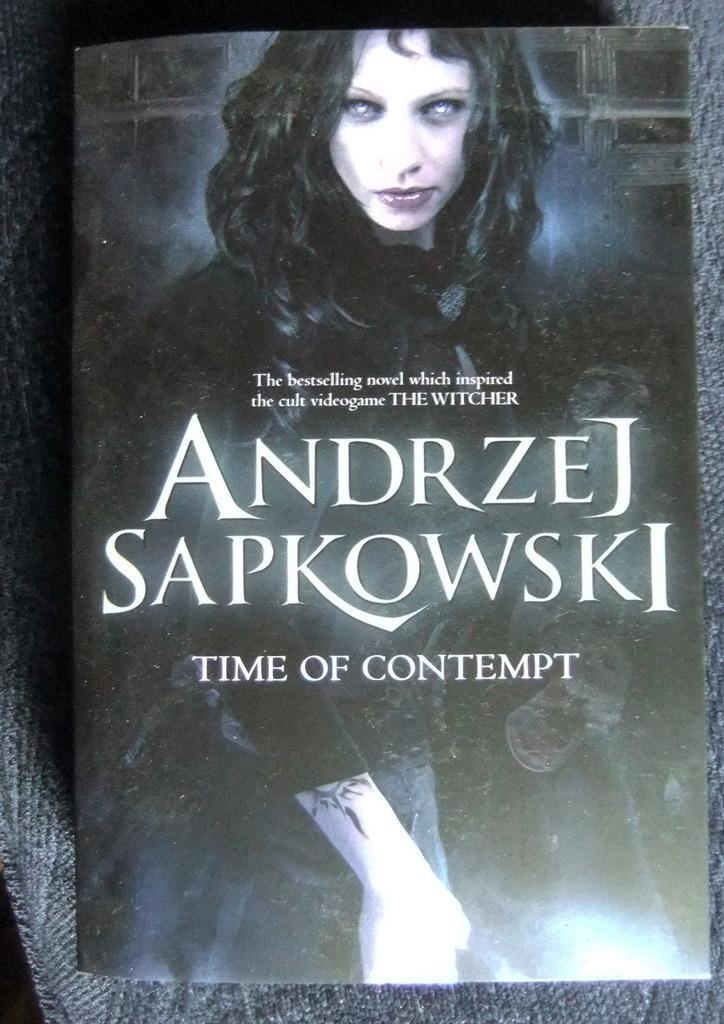Could you give a brief overview of what you see in this image? In this picture I can see there is a book it is in black color and there is a woman here, wearing a black dress and there is something written on it. The book is placed on a grey color surface. 